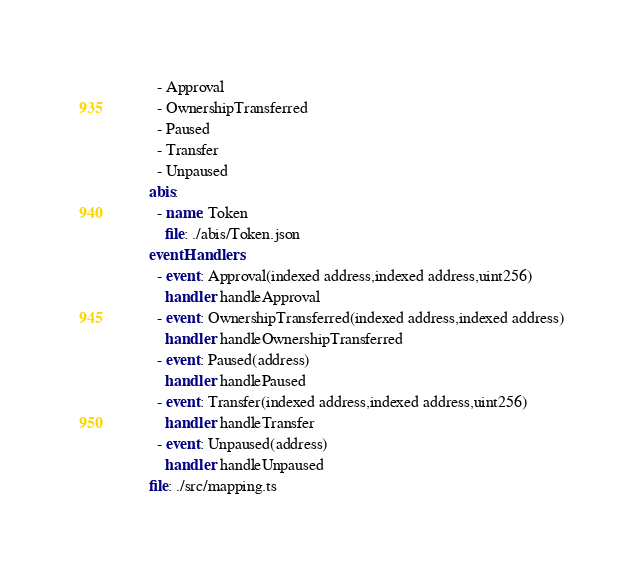Convert code to text. <code><loc_0><loc_0><loc_500><loc_500><_YAML_>        - Approval
        - OwnershipTransferred
        - Paused
        - Transfer
        - Unpaused
      abis:
        - name: Token
          file: ./abis/Token.json
      eventHandlers:
        - event: Approval(indexed address,indexed address,uint256)
          handler: handleApproval
        - event: OwnershipTransferred(indexed address,indexed address)
          handler: handleOwnershipTransferred
        - event: Paused(address)
          handler: handlePaused
        - event: Transfer(indexed address,indexed address,uint256)
          handler: handleTransfer
        - event: Unpaused(address)
          handler: handleUnpaused
      file: ./src/mapping.ts
</code> 